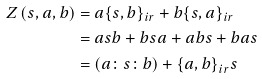<formula> <loc_0><loc_0><loc_500><loc_500>Z \left ( s , a , b \right ) & = a { { \left \{ s , b \right \} } _ { i r } } + b { { \left \{ s , a \right \} } _ { i r } } \\ & = a s b + b s a + a b s + b a s \\ & = \left ( a \colon s \colon b \right ) + { { \left \{ a , b \right \} } _ { i r } } s</formula> 